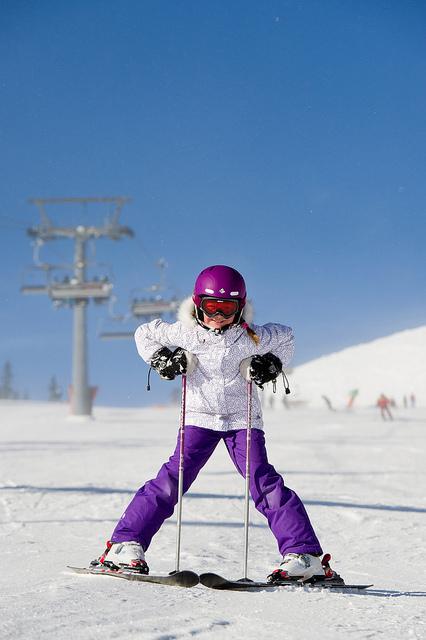Is it cold where this girl is?
Short answer required. Yes. What sport is the girl in the photo engaged in?
Keep it brief. Skiing. What color is her hoodie?
Keep it brief. White. 